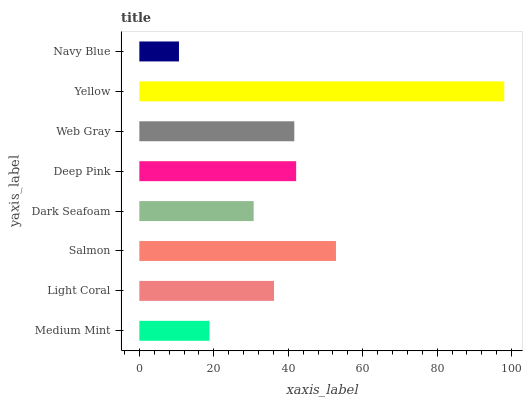Is Navy Blue the minimum?
Answer yes or no. Yes. Is Yellow the maximum?
Answer yes or no. Yes. Is Light Coral the minimum?
Answer yes or no. No. Is Light Coral the maximum?
Answer yes or no. No. Is Light Coral greater than Medium Mint?
Answer yes or no. Yes. Is Medium Mint less than Light Coral?
Answer yes or no. Yes. Is Medium Mint greater than Light Coral?
Answer yes or no. No. Is Light Coral less than Medium Mint?
Answer yes or no. No. Is Web Gray the high median?
Answer yes or no. Yes. Is Light Coral the low median?
Answer yes or no. Yes. Is Medium Mint the high median?
Answer yes or no. No. Is Web Gray the low median?
Answer yes or no. No. 